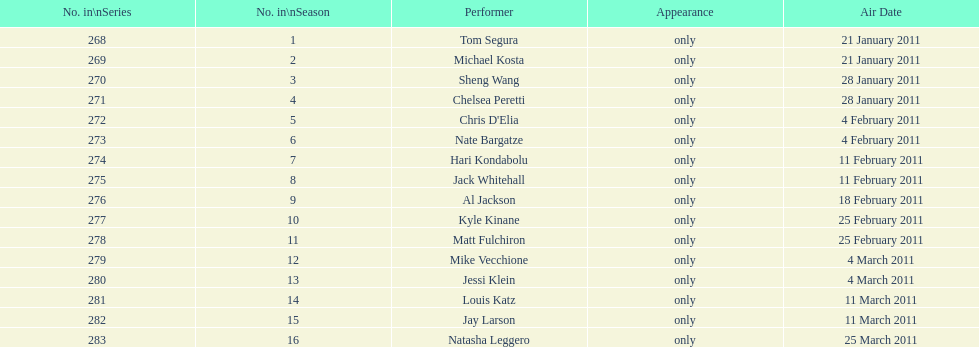How many episodes only had one performer? 16. 